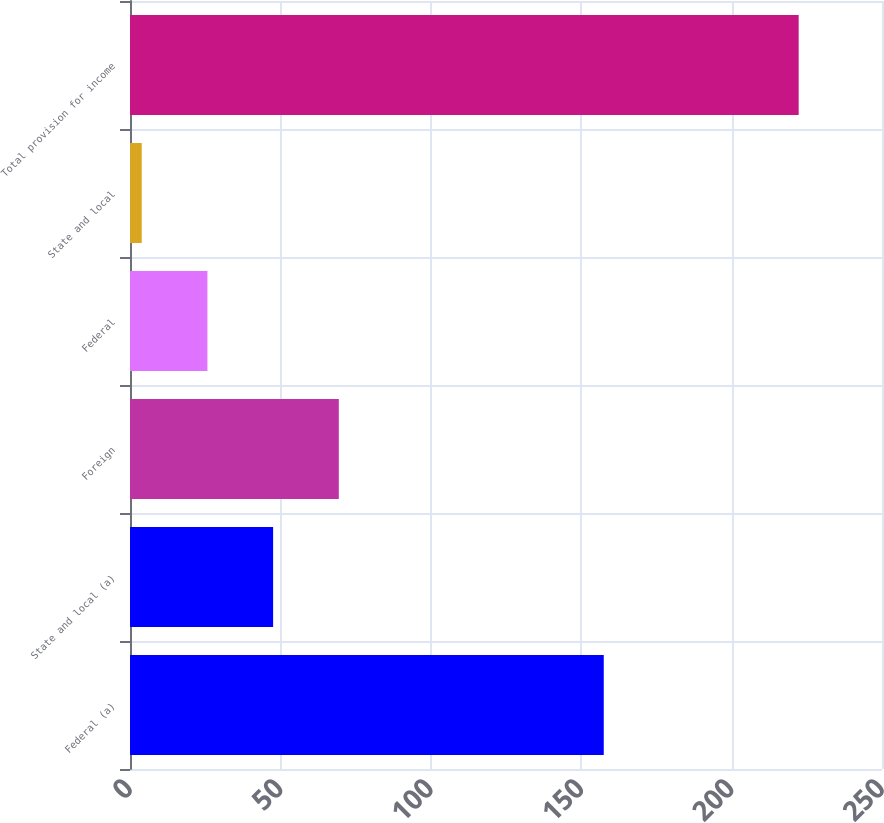Convert chart. <chart><loc_0><loc_0><loc_500><loc_500><bar_chart><fcel>Federal (a)<fcel>State and local (a)<fcel>Foreign<fcel>Federal<fcel>State and local<fcel>Total provision for income<nl><fcel>157.5<fcel>47.58<fcel>69.42<fcel>25.74<fcel>3.9<fcel>222.3<nl></chart> 